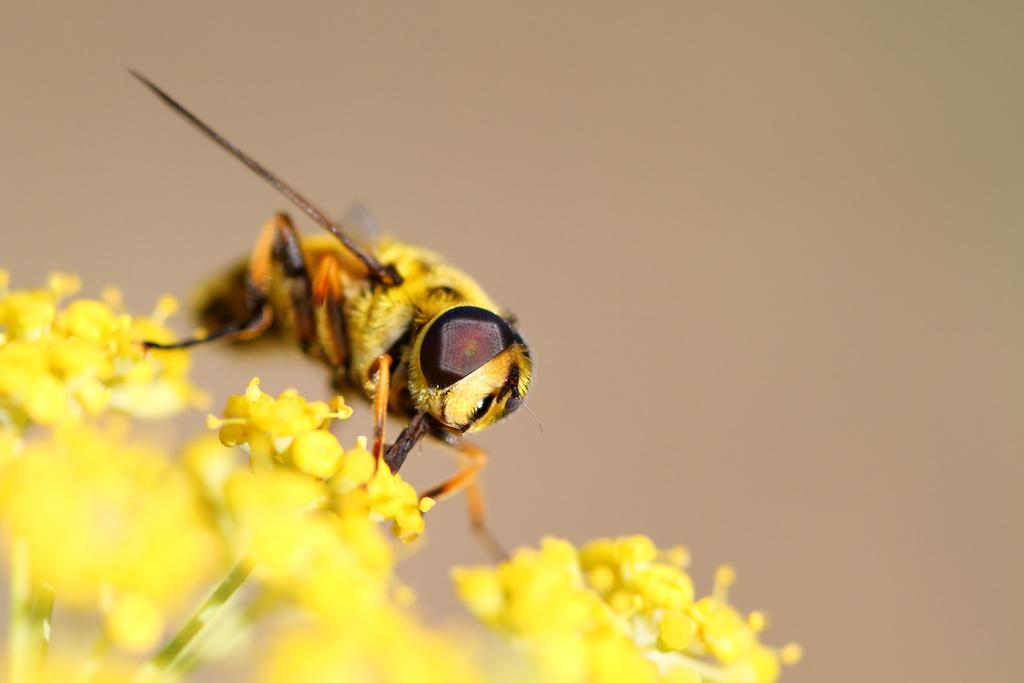What insect is present in the image? There is a bee in the image. What is the bee doing in the image? The bee is on yellow flowers. What color is the background of the image? The background of the image appears to be brown. Where might this image have been taken? The image may have been taken in a garden, given the presence of yellow flowers. What type of sign can be seen in the image? There is no sign present in the image; it features a bee on yellow flowers with a brown background. 